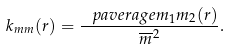Convert formula to latex. <formula><loc_0><loc_0><loc_500><loc_500>k _ { m m } ( r ) = \frac { \ p a v e r a g e { m _ { 1 } m _ { 2 } } ( r ) } { \overline { m } ^ { 2 } } .</formula> 